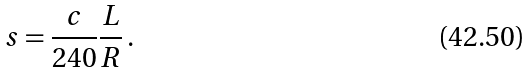Convert formula to latex. <formula><loc_0><loc_0><loc_500><loc_500>s = \frac { c } { 2 4 0 } \frac { L } { R } \, .</formula> 